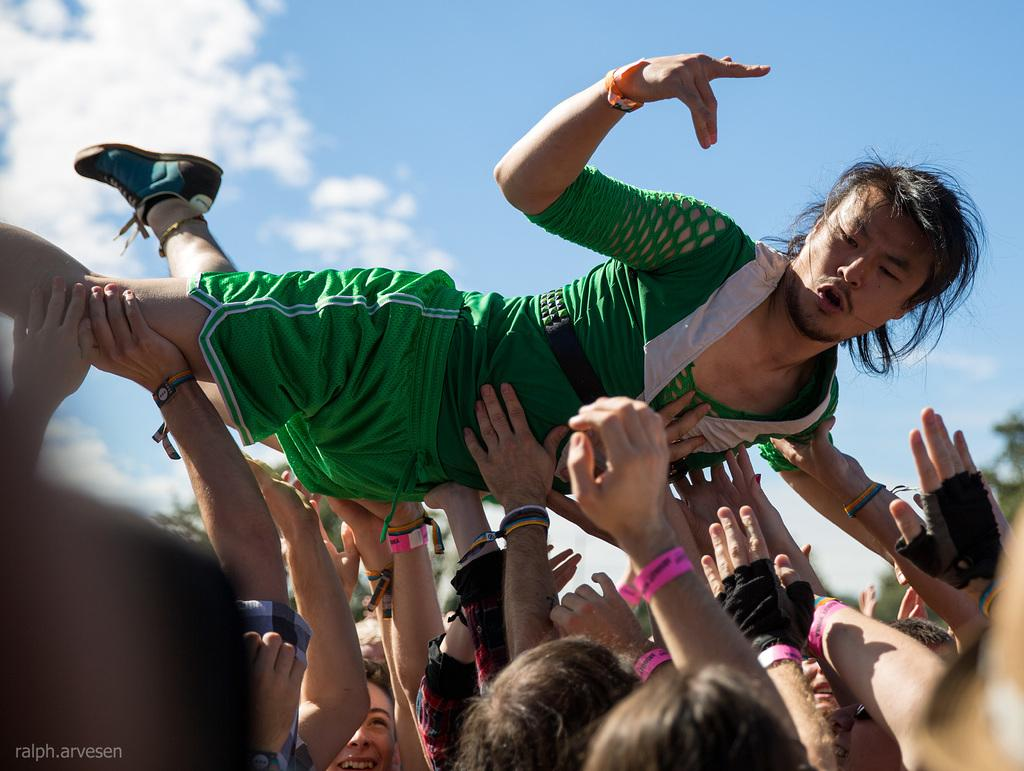How many people are in the group in the image? There is a group of people in the image, but the exact number cannot be determined from the provided facts. What is the person wearing in the group? One person in the group is wearing a green T-shirt. What are the people in the group doing? The group is lifting the person wearing the green T-shirt. What can be seen in the background of the image? There are trees in the background of the image. What is visible at the top of the image? The sky is visible at the top of the image, and clouds are present in the sky. What type of hand can be seen holding the person wearing the green T-shirt in the image? There is no hand holding the person wearing the green T-shirt in the image; the group is lifting the person together. What is the hope of the person wearing the green T-shirt in the image? There is no indication of hope or any emotions in the image; it only shows a group of people lifting the person wearing the green T-shirt. 